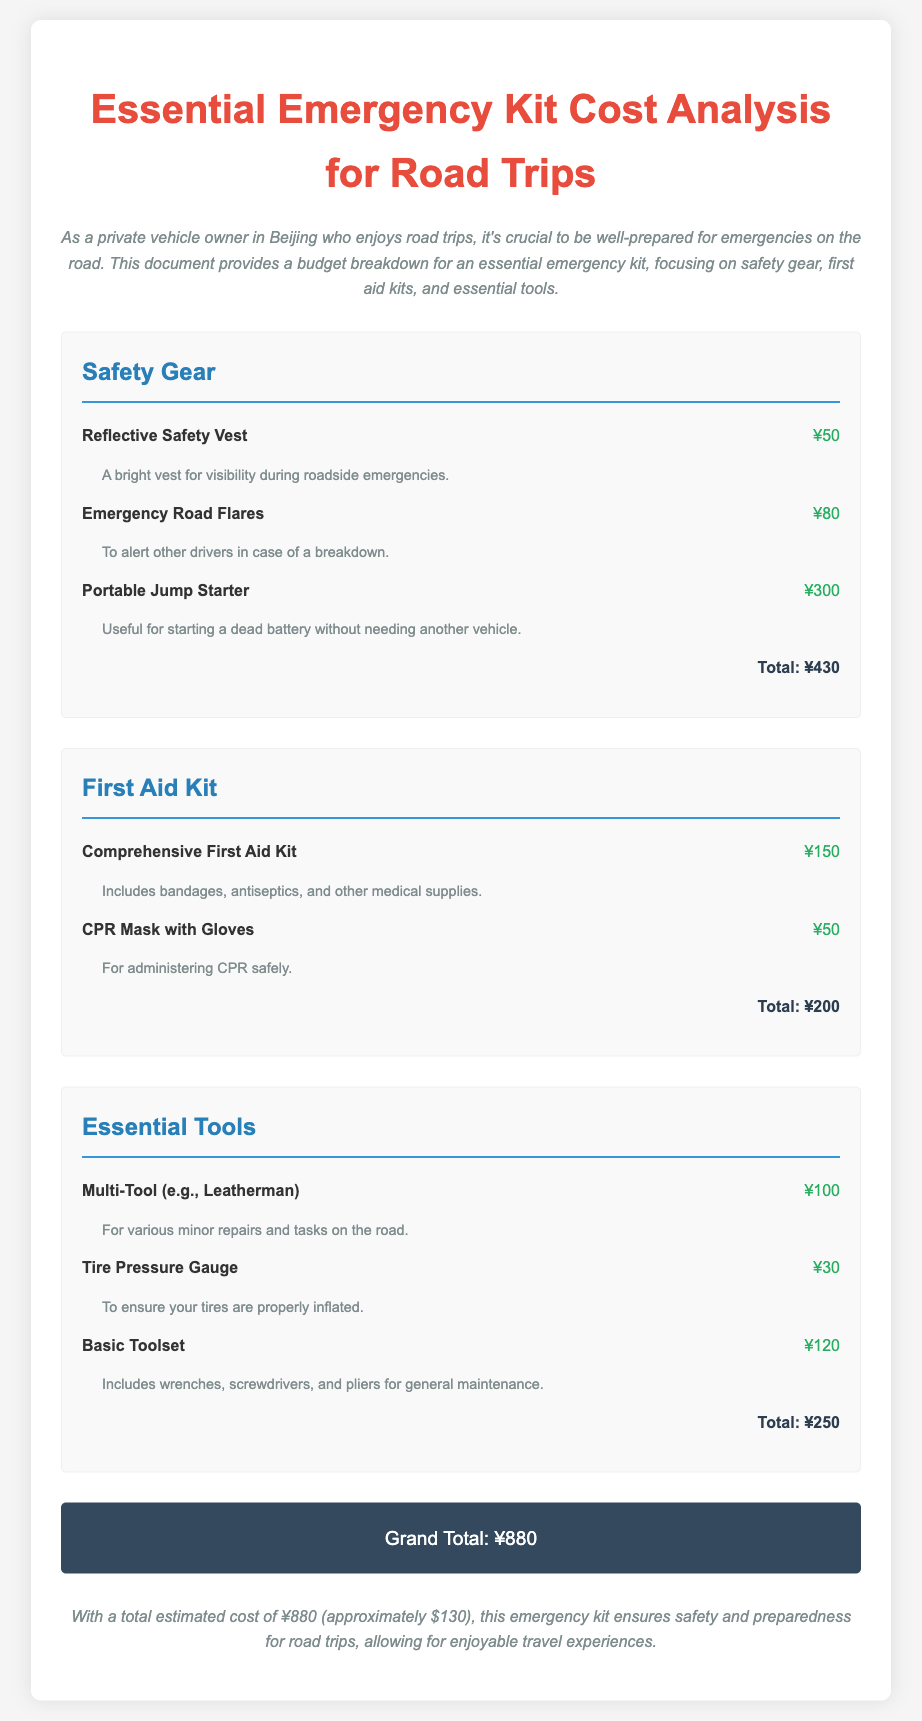What is the total cost for Safety Gear? The total cost for Safety Gear is specified in the document, which sums up the individual costs in that category.
Answer: ¥430 What items are included in the First Aid Kit category? The First Aid Kit category includes a Comprehensive First Aid Kit and a CPR Mask with Gloves, as detailed in the document.
Answer: Comprehensive First Aid Kit, CPR Mask with Gloves How much does the Portable Jump Starter cost? The cost of the Portable Jump Starter is listed in the Safety Gear section of the document.
Answer: ¥300 What is the Grand Total of the emergency kit? The Grand Total is the final amount after summing all categories of the emergency kit.
Answer: ¥880 How many items are listed under Essential Tools? The document provides the individual item counts for each category, specifically within Essential Tools.
Answer: 3 What does the Comprehensive First Aid Kit include? The description mentions that the Comprehensive First Aid Kit includes bandages, antiseptics, and other medical supplies.
Answer: bandages, antiseptics, and other medical supplies What is the purpose of the Emergency Road Flares? The document describes the purpose of the Emergency Road Flares in the Safety Gear category.
Answer: To alert other drivers in case of a breakdown How much does the Tire Pressure Gauge cost? The cost of the Tire Pressure Gauge is explicitly stated in the Essential Tools category.
Answer: ¥30 What color is the Grand Total section? The document specifies different colors for sections, particularly for the Grand Total.
Answer: White What is the introductory statement's focus? The introduction sets the context for the budget breakdown and its importance for road trips.
Answer: safety and preparedness for road trips 